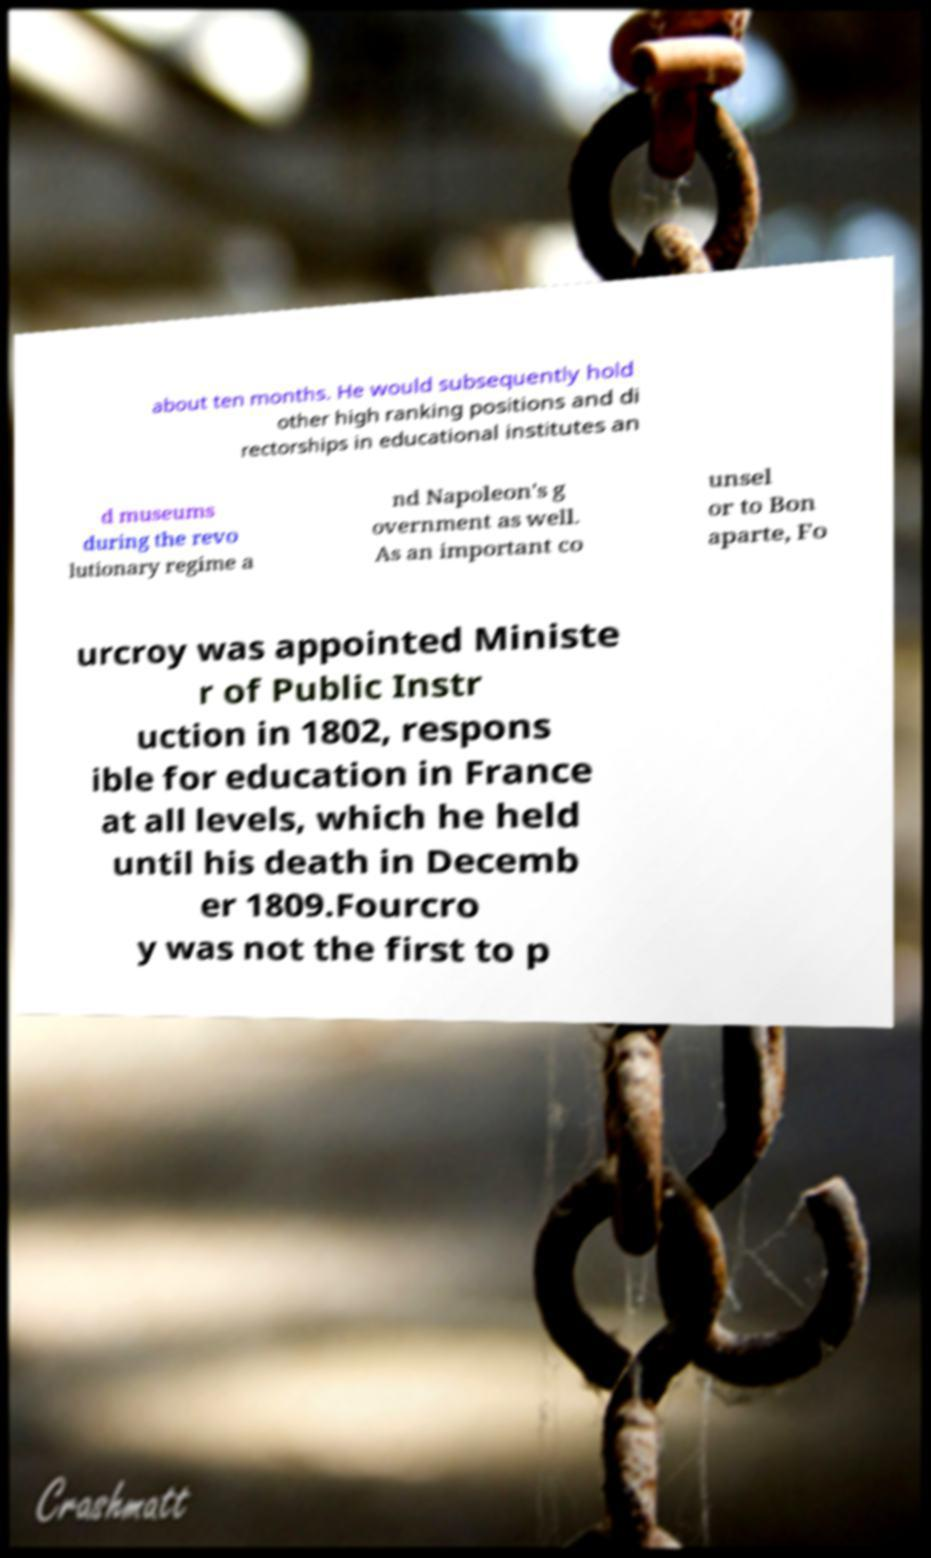I need the written content from this picture converted into text. Can you do that? about ten months. He would subsequently hold other high ranking positions and di rectorships in educational institutes an d museums during the revo lutionary regime a nd Napoleon's g overnment as well. As an important co unsel or to Bon aparte, Fo urcroy was appointed Ministe r of Public Instr uction in 1802, respons ible for education in France at all levels, which he held until his death in Decemb er 1809.Fourcro y was not the first to p 